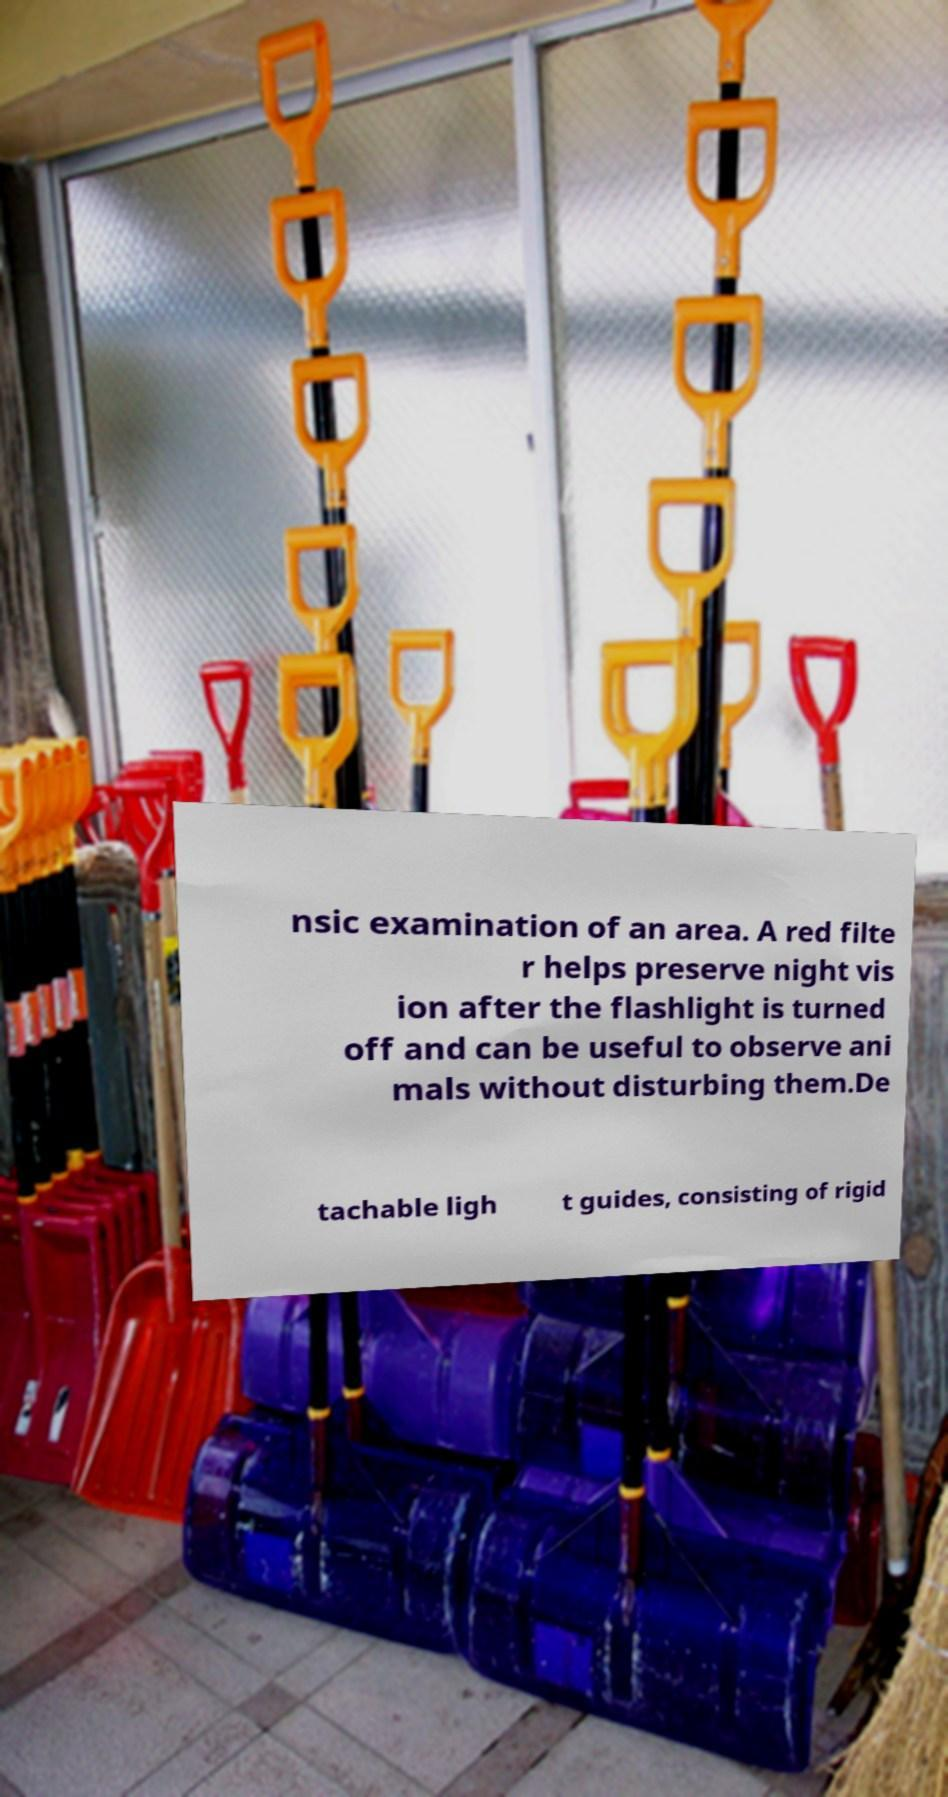Could you assist in decoding the text presented in this image and type it out clearly? nsic examination of an area. A red filte r helps preserve night vis ion after the flashlight is turned off and can be useful to observe ani mals without disturbing them.De tachable ligh t guides, consisting of rigid 